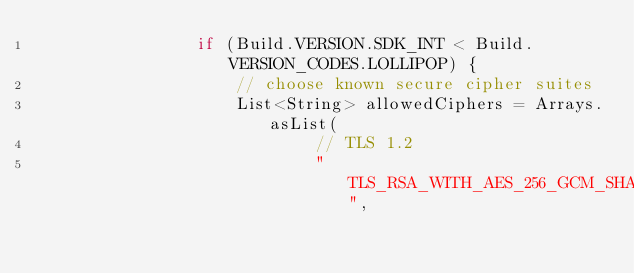Convert code to text. <code><loc_0><loc_0><loc_500><loc_500><_Java_>                if (Build.VERSION.SDK_INT < Build.VERSION_CODES.LOLLIPOP) {
                    // choose known secure cipher suites
                    List<String> allowedCiphers = Arrays.asList(
                            // TLS 1.2
                            "TLS_RSA_WITH_AES_256_GCM_SHA384",</code> 